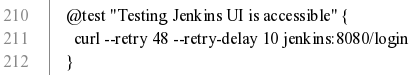<code> <loc_0><loc_0><loc_500><loc_500><_YAML_>    @test "Testing Jenkins UI is accessible" {
      curl --retry 48 --retry-delay 10 jenkins:8080/login
    }
</code> 